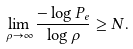<formula> <loc_0><loc_0><loc_500><loc_500>\lim _ { \rho \rightarrow \infty } \frac { - \log P _ { e } } { \log \rho } \geq N .</formula> 